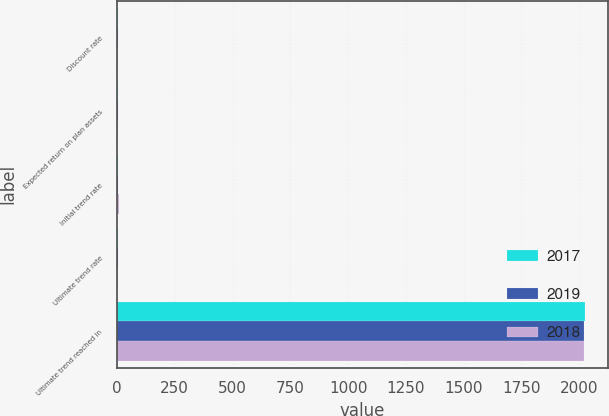Convert chart to OTSL. <chart><loc_0><loc_0><loc_500><loc_500><stacked_bar_chart><ecel><fcel>Discount rate<fcel>Expected return on plan assets<fcel>Initial trend rate<fcel>Ultimate trend rate<fcel>Ultimate trend reached in<nl><fcel>2017<fcel>3.29<fcel>5.14<fcel>6.25<fcel>5<fcel>2025<nl><fcel>2019<fcel>4.38<fcel>5.33<fcel>6.5<fcel>5<fcel>2022<nl><fcel>2018<fcel>3.73<fcel>4.45<fcel>7.5<fcel>5<fcel>2022<nl></chart> 